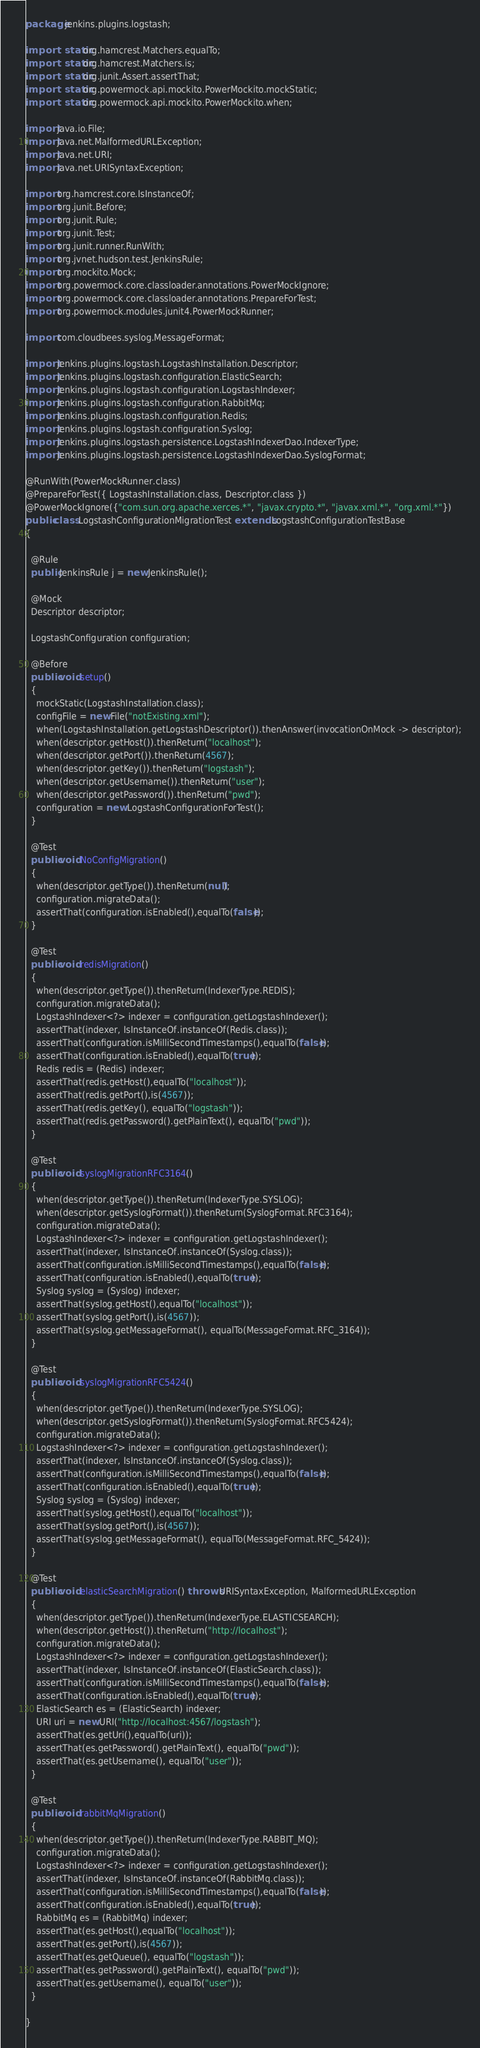<code> <loc_0><loc_0><loc_500><loc_500><_Java_>package jenkins.plugins.logstash;

import static org.hamcrest.Matchers.equalTo;
import static org.hamcrest.Matchers.is;
import static org.junit.Assert.assertThat;
import static org.powermock.api.mockito.PowerMockito.mockStatic;
import static org.powermock.api.mockito.PowerMockito.when;

import java.io.File;
import java.net.MalformedURLException;
import java.net.URI;
import java.net.URISyntaxException;

import org.hamcrest.core.IsInstanceOf;
import org.junit.Before;
import org.junit.Rule;
import org.junit.Test;
import org.junit.runner.RunWith;
import org.jvnet.hudson.test.JenkinsRule;
import org.mockito.Mock;
import org.powermock.core.classloader.annotations.PowerMockIgnore;
import org.powermock.core.classloader.annotations.PrepareForTest;
import org.powermock.modules.junit4.PowerMockRunner;

import com.cloudbees.syslog.MessageFormat;

import jenkins.plugins.logstash.LogstashInstallation.Descriptor;
import jenkins.plugins.logstash.configuration.ElasticSearch;
import jenkins.plugins.logstash.configuration.LogstashIndexer;
import jenkins.plugins.logstash.configuration.RabbitMq;
import jenkins.plugins.logstash.configuration.Redis;
import jenkins.plugins.logstash.configuration.Syslog;
import jenkins.plugins.logstash.persistence.LogstashIndexerDao.IndexerType;
import jenkins.plugins.logstash.persistence.LogstashIndexerDao.SyslogFormat;

@RunWith(PowerMockRunner.class)
@PrepareForTest({ LogstashInstallation.class, Descriptor.class })
@PowerMockIgnore({"com.sun.org.apache.xerces.*", "javax.crypto.*", "javax.xml.*", "org.xml.*"})
public class LogstashConfigurationMigrationTest extends LogstashConfigurationTestBase
{

  @Rule
  public JenkinsRule j = new JenkinsRule();

  @Mock
  Descriptor descriptor;

  LogstashConfiguration configuration;

  @Before
  public void setup()
  {
    mockStatic(LogstashInstallation.class);
    configFile = new File("notExisting.xml");
    when(LogstashInstallation.getLogstashDescriptor()).thenAnswer(invocationOnMock -> descriptor);
    when(descriptor.getHost()).thenReturn("localhost");
    when(descriptor.getPort()).thenReturn(4567);
    when(descriptor.getKey()).thenReturn("logstash");
    when(descriptor.getUsername()).thenReturn("user");
    when(descriptor.getPassword()).thenReturn("pwd");
    configuration = new LogstashConfigurationForTest();
  }

  @Test
  public void NoConfigMigration()
  {
    when(descriptor.getType()).thenReturn(null);
    configuration.migrateData();
    assertThat(configuration.isEnabled(),equalTo(false));
  }

  @Test
  public void redisMigration()
  {
    when(descriptor.getType()).thenReturn(IndexerType.REDIS);
    configuration.migrateData();
    LogstashIndexer<?> indexer = configuration.getLogstashIndexer();
    assertThat(indexer, IsInstanceOf.instanceOf(Redis.class));
    assertThat(configuration.isMilliSecondTimestamps(),equalTo(false));
    assertThat(configuration.isEnabled(),equalTo(true));
    Redis redis = (Redis) indexer;
    assertThat(redis.getHost(),equalTo("localhost"));
    assertThat(redis.getPort(),is(4567));
    assertThat(redis.getKey(), equalTo("logstash"));
    assertThat(redis.getPassword().getPlainText(), equalTo("pwd"));
  }

  @Test
  public void syslogMigrationRFC3164()
  {
    when(descriptor.getType()).thenReturn(IndexerType.SYSLOG);
    when(descriptor.getSyslogFormat()).thenReturn(SyslogFormat.RFC3164);
    configuration.migrateData();
    LogstashIndexer<?> indexer = configuration.getLogstashIndexer();
    assertThat(indexer, IsInstanceOf.instanceOf(Syslog.class));
    assertThat(configuration.isMilliSecondTimestamps(),equalTo(false));
    assertThat(configuration.isEnabled(),equalTo(true));
    Syslog syslog = (Syslog) indexer;
    assertThat(syslog.getHost(),equalTo("localhost"));
    assertThat(syslog.getPort(),is(4567));
    assertThat(syslog.getMessageFormat(), equalTo(MessageFormat.RFC_3164));
  }

  @Test
  public void syslogMigrationRFC5424()
  {
    when(descriptor.getType()).thenReturn(IndexerType.SYSLOG);
    when(descriptor.getSyslogFormat()).thenReturn(SyslogFormat.RFC5424);
    configuration.migrateData();
    LogstashIndexer<?> indexer = configuration.getLogstashIndexer();
    assertThat(indexer, IsInstanceOf.instanceOf(Syslog.class));
    assertThat(configuration.isMilliSecondTimestamps(),equalTo(false));
    assertThat(configuration.isEnabled(),equalTo(true));
    Syslog syslog = (Syslog) indexer;
    assertThat(syslog.getHost(),equalTo("localhost"));
    assertThat(syslog.getPort(),is(4567));
    assertThat(syslog.getMessageFormat(), equalTo(MessageFormat.RFC_5424));
  }

  @Test
  public void elasticSearchMigration() throws URISyntaxException, MalformedURLException
  {
    when(descriptor.getType()).thenReturn(IndexerType.ELASTICSEARCH);
    when(descriptor.getHost()).thenReturn("http://localhost");
    configuration.migrateData();
    LogstashIndexer<?> indexer = configuration.getLogstashIndexer();
    assertThat(indexer, IsInstanceOf.instanceOf(ElasticSearch.class));
    assertThat(configuration.isMilliSecondTimestamps(),equalTo(false));
    assertThat(configuration.isEnabled(),equalTo(true));
    ElasticSearch es = (ElasticSearch) indexer;
    URI uri = new URI("http://localhost:4567/logstash");
    assertThat(es.getUri(),equalTo(uri));
    assertThat(es.getPassword().getPlainText(), equalTo("pwd"));
    assertThat(es.getUsername(), equalTo("user"));
  }

  @Test
  public void rabbitMqMigration()
  {
    when(descriptor.getType()).thenReturn(IndexerType.RABBIT_MQ);
    configuration.migrateData();
    LogstashIndexer<?> indexer = configuration.getLogstashIndexer();
    assertThat(indexer, IsInstanceOf.instanceOf(RabbitMq.class));
    assertThat(configuration.isMilliSecondTimestamps(),equalTo(false));
    assertThat(configuration.isEnabled(),equalTo(true));
    RabbitMq es = (RabbitMq) indexer;
    assertThat(es.getHost(),equalTo("localhost"));
    assertThat(es.getPort(),is(4567));
    assertThat(es.getQueue(), equalTo("logstash"));
    assertThat(es.getPassword().getPlainText(), equalTo("pwd"));
    assertThat(es.getUsername(), equalTo("user"));
  }

}
</code> 